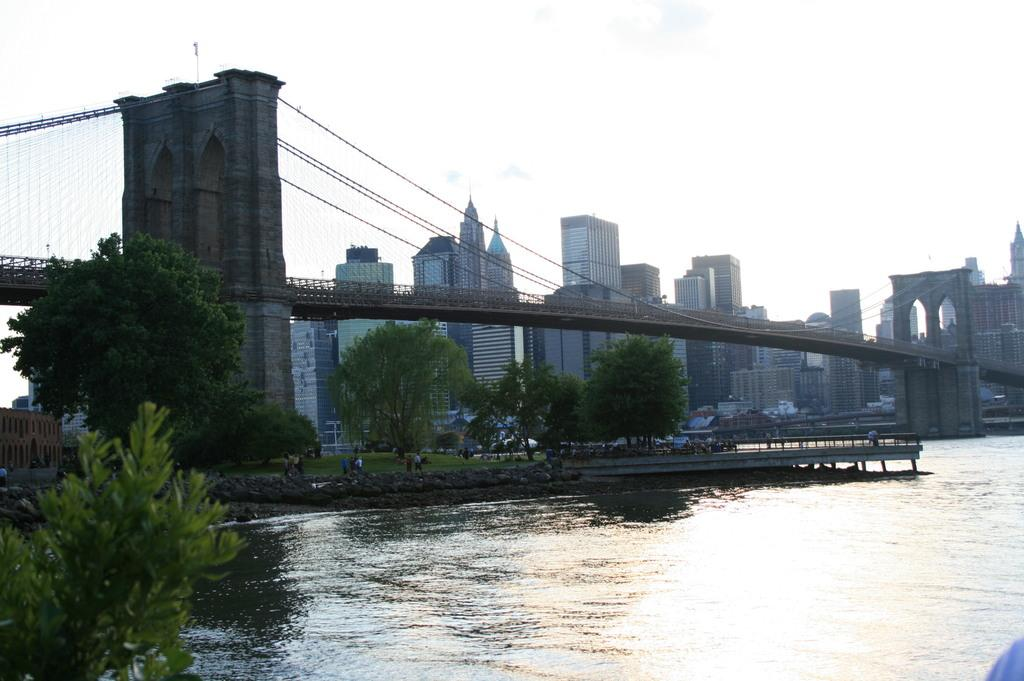What is the primary element visible in the image? There is water in the image. What type of vegetation is present near the water? There are trees on the sides of the water. Can you describe the people in the image? There are people in the image. What type of structure is present over the water? There is a bridge with pillars in the image. What can be seen in the background of the image? There are buildings in the background of the image. What is visible above the water and buildings? The sky is visible in the image. How many dolls are sitting in jail in the image? There are no dolls or jails present in the image. What type of ducks can be seen swimming in the water in the image? There are no ducks visible in the water in the image. 